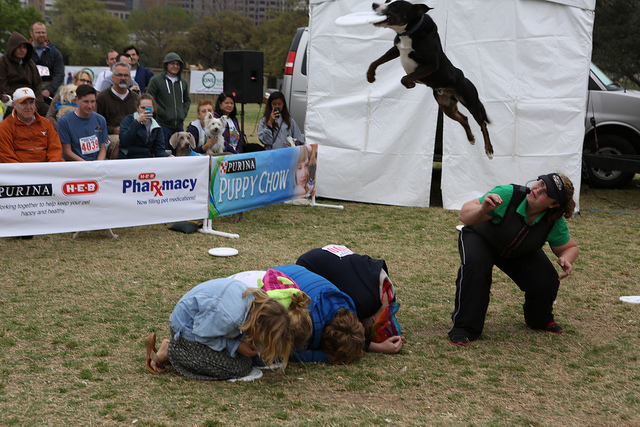<image>Where is this event taking place? It isn't clear where exactly this event is taking place, but it seems to be happening outdoors, possibly at a dog show or park. Where is this event taking place? I don't know where this event is taking place. It could be outdoors, at a dog show, or at a dog olympics. 